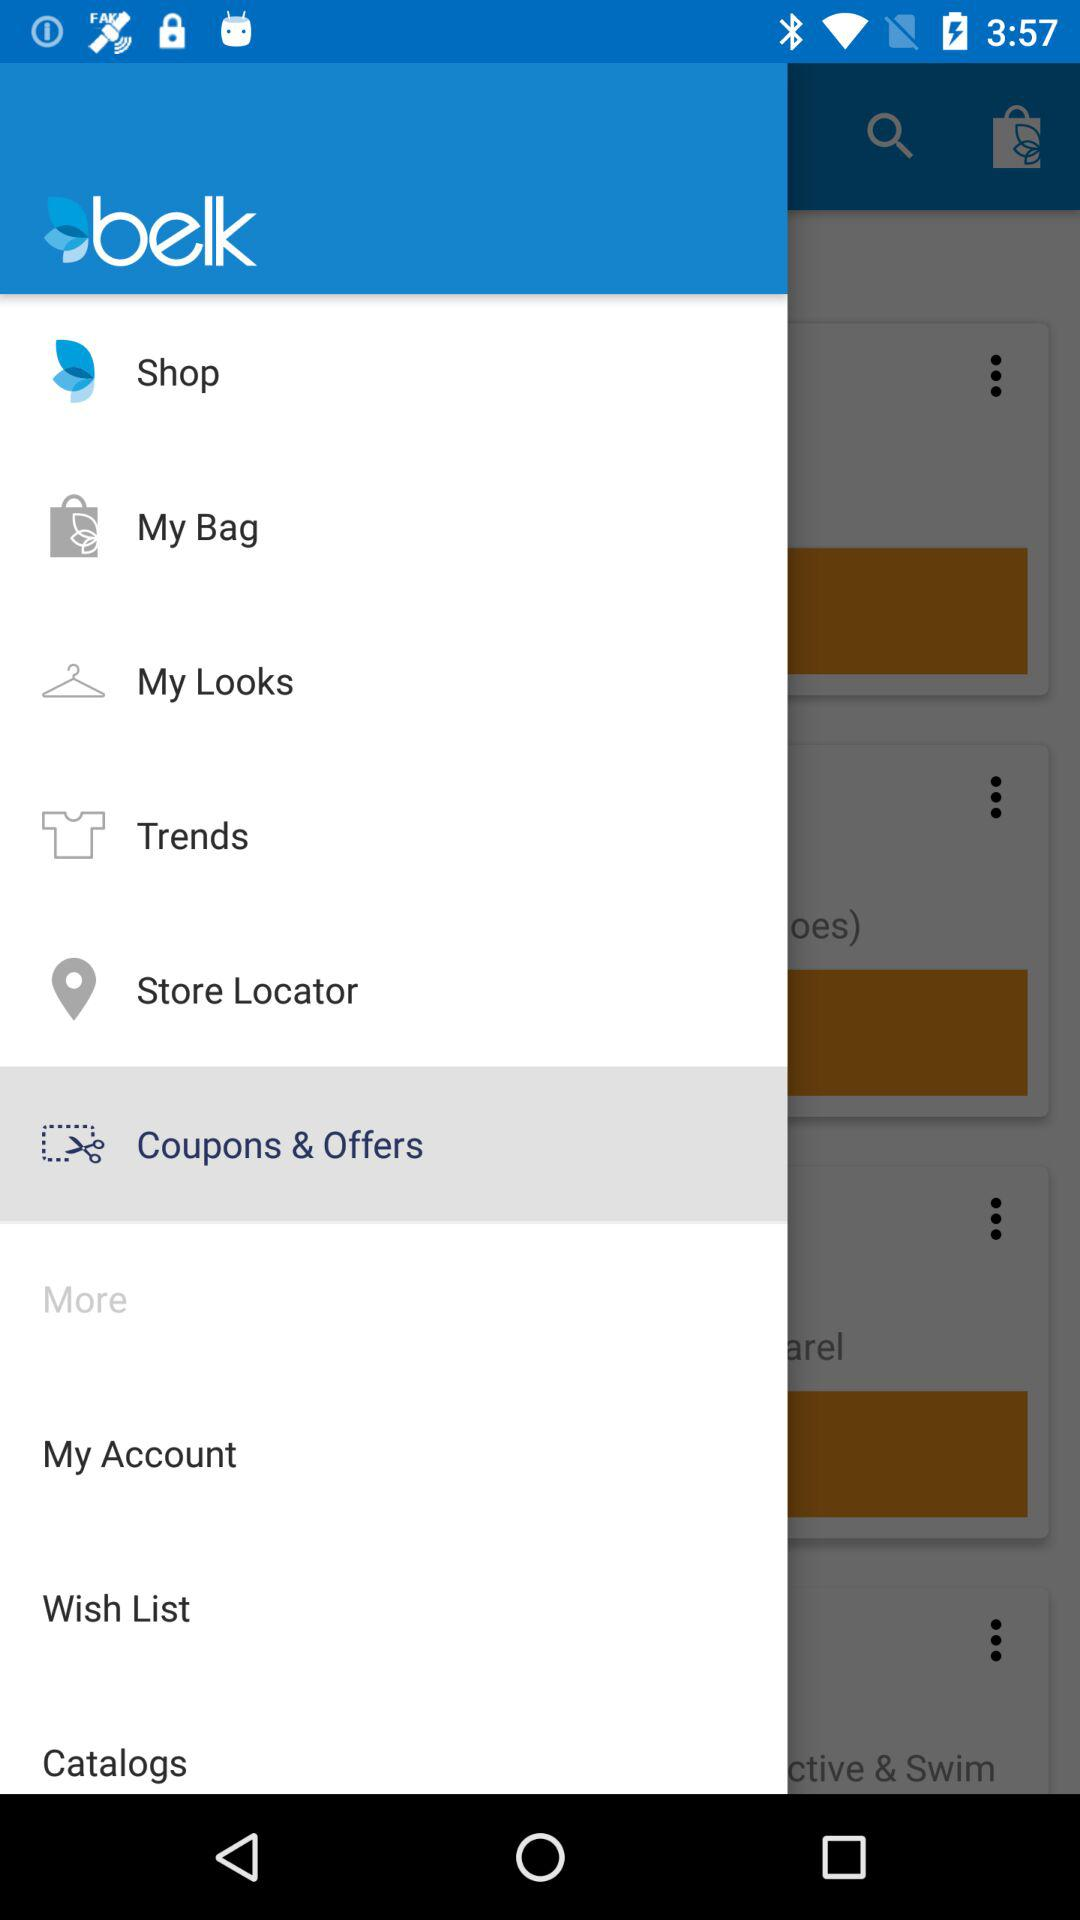What is the app name? The app name is "belk". 